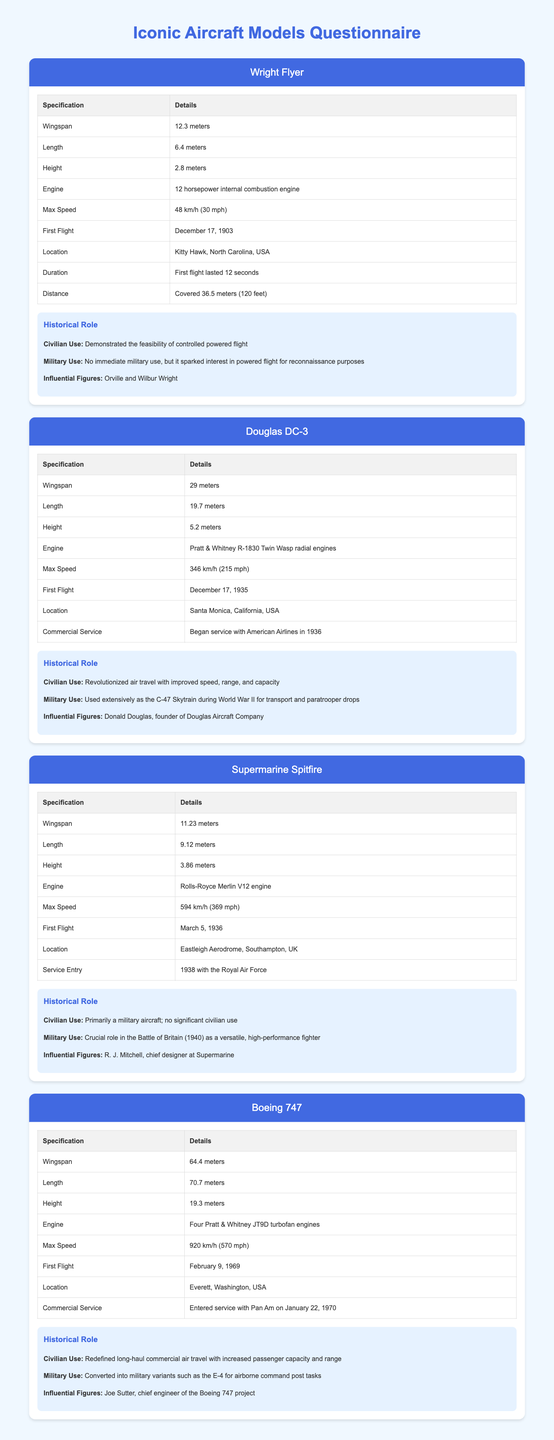What is the wingspan of the Wright Flyer? The wingspan is listed in the specifications table for the Wright Flyer, which is 12.3 meters.
Answer: 12.3 meters When did the Douglas DC-3 first fly? The first flight date of the Douglas DC-3 is specified as December 17, 1935 in the document.
Answer: December 17, 1935 What was the max speed of the Supermarine Spitfire? The max speed is provided in the specifications table for the Supermarine Spitfire, which is 594 km/h.
Answer: 594 km/h What historical event is the Supermarine Spitfire known for? The document mentions that the Supermarine Spitfire played a crucial role in the Battle of Britain.
Answer: Battle of Britain Who was the chief engineer of the Boeing 747 project? The influential figure related to the Boeing 747 project is stated as Joe Sutter in the historical role section.
Answer: Joe Sutter 